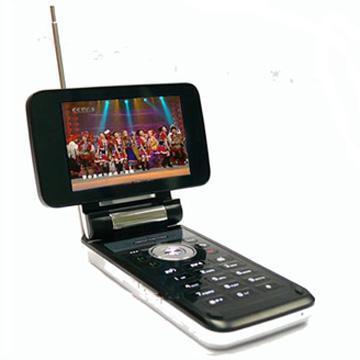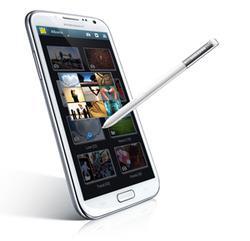The first image is the image on the left, the second image is the image on the right. Assess this claim about the two images: "One image shows a device with a flipped up horizontal, wide screen with something displaying on the screen.". Correct or not? Answer yes or no. Yes. The first image is the image on the left, the second image is the image on the right. Considering the images on both sides, is "In at least one image a there is a single phone with physical buttons on the bottom half of the phone that is attached to a phone screen that is long left to right than up and down." valid? Answer yes or no. Yes. 